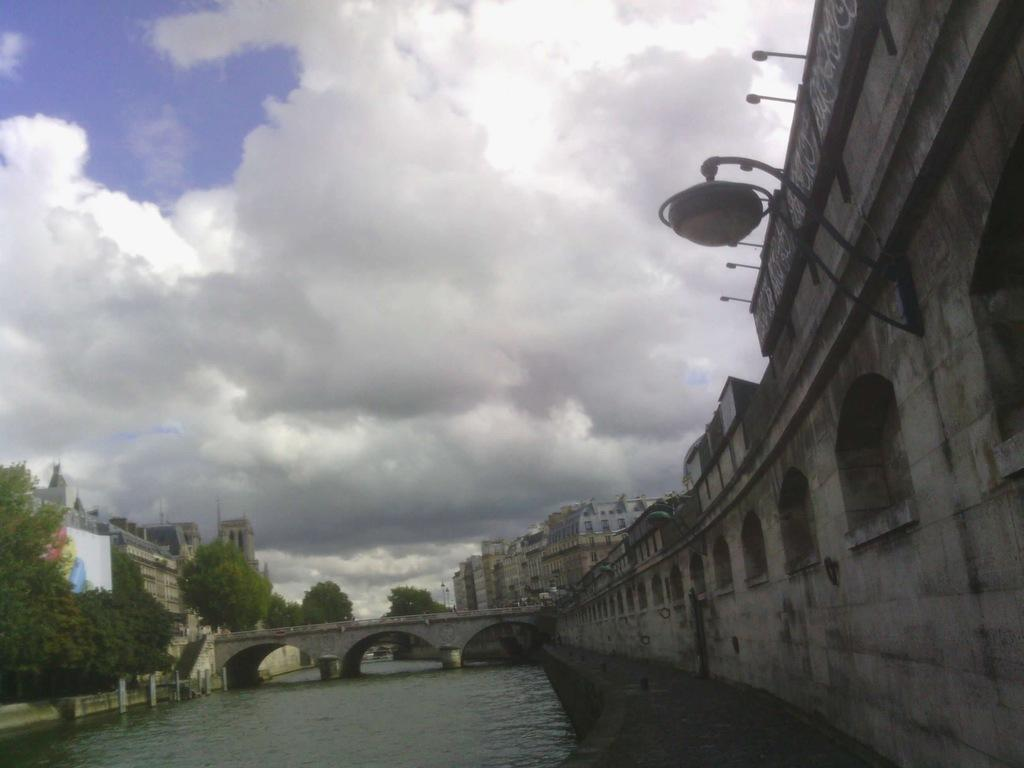What natural feature is present in the image? There is a river in the image. What structure crosses over the river? There is a bridge over the river. What can be seen on the right side of the image? There is a wall on the right side of the image. What type of vegetation is present around the river? There are many trees around the river. What type of man-made structures are visible in the image? There are buildings visible in the image. What type of quartz can be seen in the image? There is no quartz present in the image. What color are the cushions on the bridge in the image? There are no cushions present in the image. 